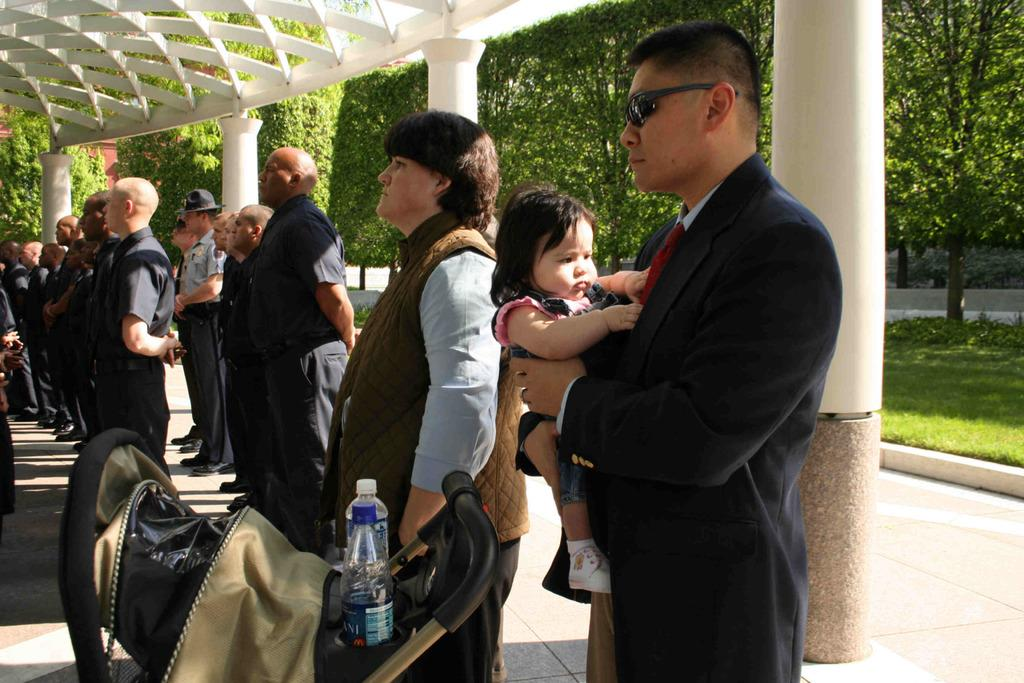What is happening with the group of people in the image? There is a group of people standing on the floor. What object related to babies can be seen in the image? There is a stroller in the image. What items are visible that might be used for feeding or hydration? There are bottles in the image. What is the man in the image doing? A man is carrying a child. What architectural features can be seen in the background of the image? There are pillars and a roof visible in the background. What type of natural environment is visible in the background of the image? Grass, trees, and possibly a park or garden are visible in the background. What type of zinc is present in the image? There is no zinc present in the image. What error can be seen in the image? There is no error visible in the image. 